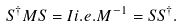<formula> <loc_0><loc_0><loc_500><loc_500>S ^ { \dagger } M S = I i . e . M ^ { - 1 } = S S ^ { \dagger } .</formula> 